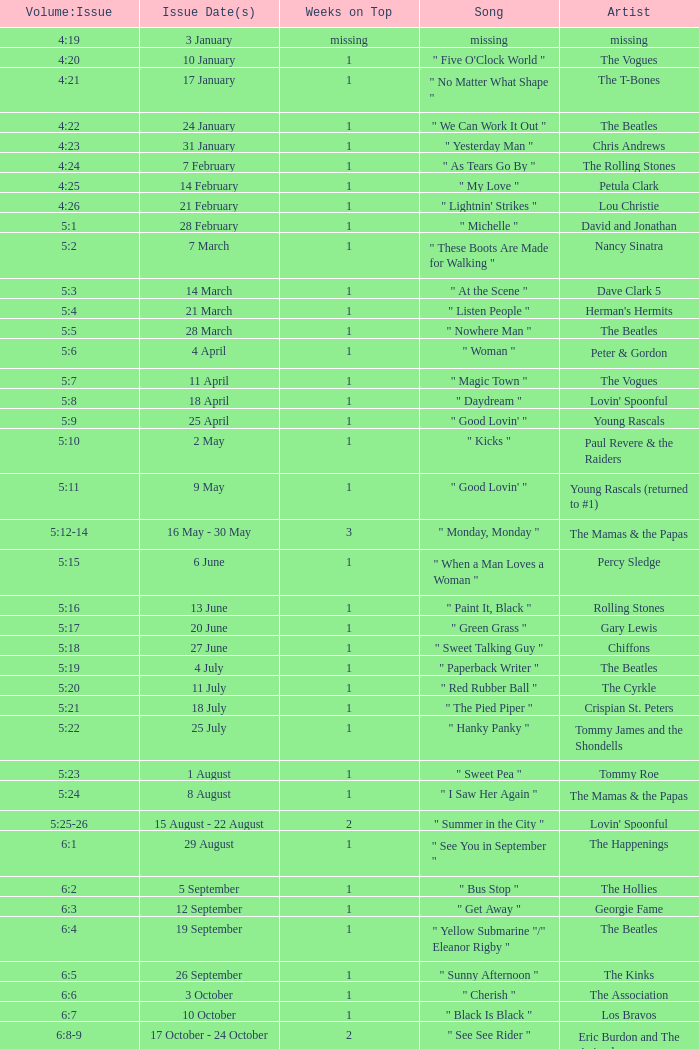A member of the beatles with a problem date(s) of 19 september has what as the mentioned weeks on the summit? 1.0. 